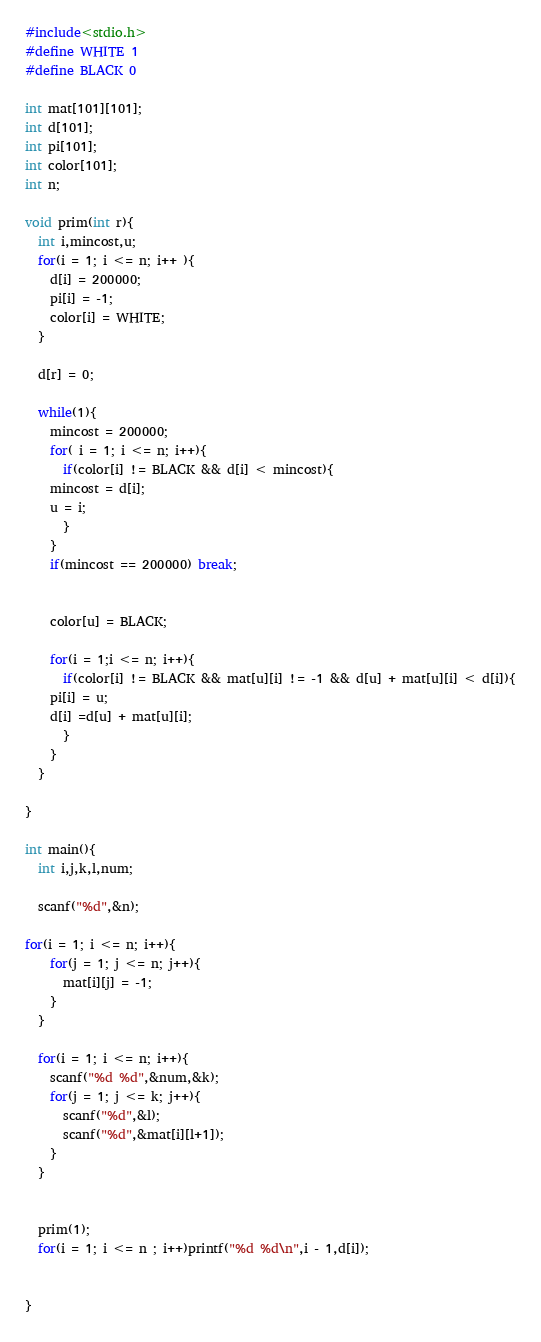Convert code to text. <code><loc_0><loc_0><loc_500><loc_500><_C_>#include<stdio.h>
#define WHITE 1
#define BLACK 0

int mat[101][101];
int d[101];
int pi[101];
int color[101];
int n;

void prim(int r){
  int i,mincost,u;
  for(i = 1; i <= n; i++ ){
    d[i] = 200000;
    pi[i] = -1;
    color[i] = WHITE;
  }

  d[r] = 0;

  while(1){
    mincost = 200000;
    for( i = 1; i <= n; i++){
      if(color[i] != BLACK && d[i] < mincost){
	mincost = d[i];
	u = i;
      }
    }
    if(mincost == 200000) break;
    

    color[u] = BLACK;

    for(i = 1;i <= n; i++){
      if(color[i] != BLACK && mat[u][i] != -1 && d[u] + mat[u][i] < d[i]){
	pi[i] = u;
	d[i] =d[u] + mat[u][i];
      }
    }
  }
  
}

int main(){
  int i,j,k,l,num;

  scanf("%d",&n);

for(i = 1; i <= n; i++){
    for(j = 1; j <= n; j++){
      mat[i][j] = -1;
    }
  }

  for(i = 1; i <= n; i++){
    scanf("%d %d",&num,&k);
    for(j = 1; j <= k; j++){
      scanf("%d",&l);
      scanf("%d",&mat[i][l+1]);
    }
  }
  

  prim(1);
  for(i = 1; i <= n ; i++)printf("%d %d\n",i - 1,d[i]);
  
  
}

</code> 